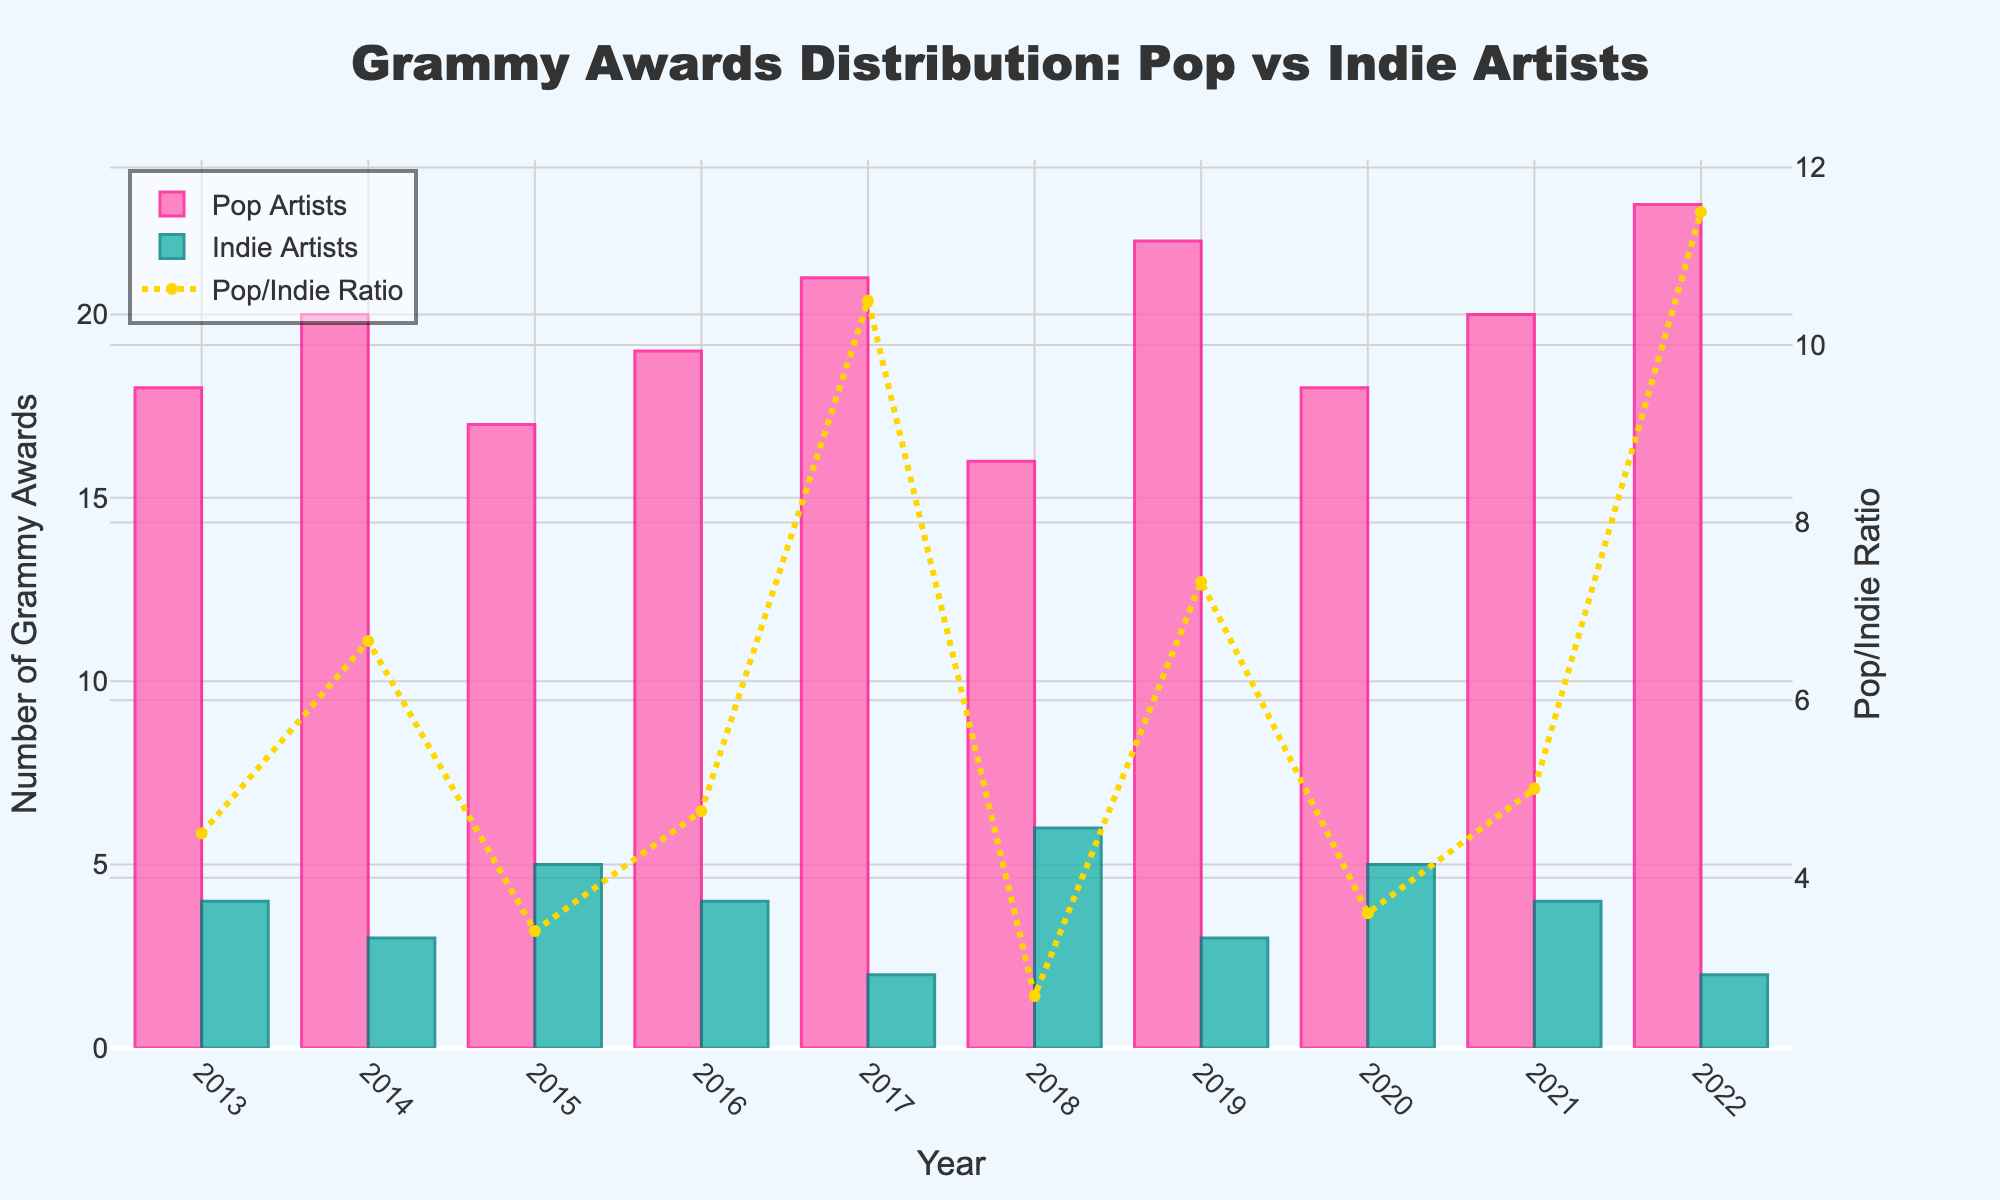What's the total number of Grammy Awards won by Pop Artists over the last decade? Summing up the number of Grammy Awards won by Pop Artists over each year: 18 + 20 + 17 + 19 + 21 + 16 + 22 + 18 + 20 + 23 = 194
Answer: 194 In which year did Indie Artists win the most Grammy Awards? By observing the height of the bars representing Indie Artists, the tallest bar appears in 2018 with 6 Grammy Awards.
Answer: 2018 How does the number of Grammy Awards won by Pop Artists in 2022 compare to 2013? The bar for Pop Artists in 2022 is taller and shows 23 Grammy Awards, whereas in 2013 it shows 18 Grammy Awards. Therefore, Pop Artists won 5 more Grammy Awards in 2022 than in 2013.
Answer: 5 more What is the average number of Grammy Awards won by Indie Artists over these ten years? Summing the number of Grammy Awards for Indie Artists: 4 + 3 + 5 + 4 + 2 + 6 + 3 + 5 + 4 + 2 = 38. The average is 38 divided by 10 years, which is 3.8 Grammy Awards per year.
Answer: 3.8 What year had the highest ratio of Grammy Awards won by Pop Artists to Indie Artists? Looking at the yellow dotted line representing the ratio, the highest peak occurs in 2022.
Answer: 2022 Which year showed the greatest difference in Grammy Awards between Pop and Indie Artists? Subtracting Indie Artists' Grammy Awards from Pop Artists' for each year and comparing the differences, 2022 has the largest difference (23 - 2 = 21).
Answer: 2022 How many more Grammy Awards did Pop Artists win than Indie Artists in 2019? Pop Artists won 22, and Indie Artists won 3 in 2019. The difference is 22 - 3 = 19.
Answer: 19 What's the combined number of Grammy Awards won by both Pop and Indie Artists in 2017 compared to 2020? In 2017, Pop Artists won 21 and Indie Artists 2 (21 + 2 = 23). In 2020, Pop Artists won 18 and Indie Artists 5 (18 + 5 = 23). Both years had a combined total of 23 Grammy Awards.
Answer: Both years are equal at 23 How much did the number of Grammy Awards won by Indie Artists increase or decrease from 2017 to 2018? Indie Artists won 2 Awards in 2017 and 6 Awards in 2018. The increase is 6 - 2 = 4.
Answer: Increased by 4 